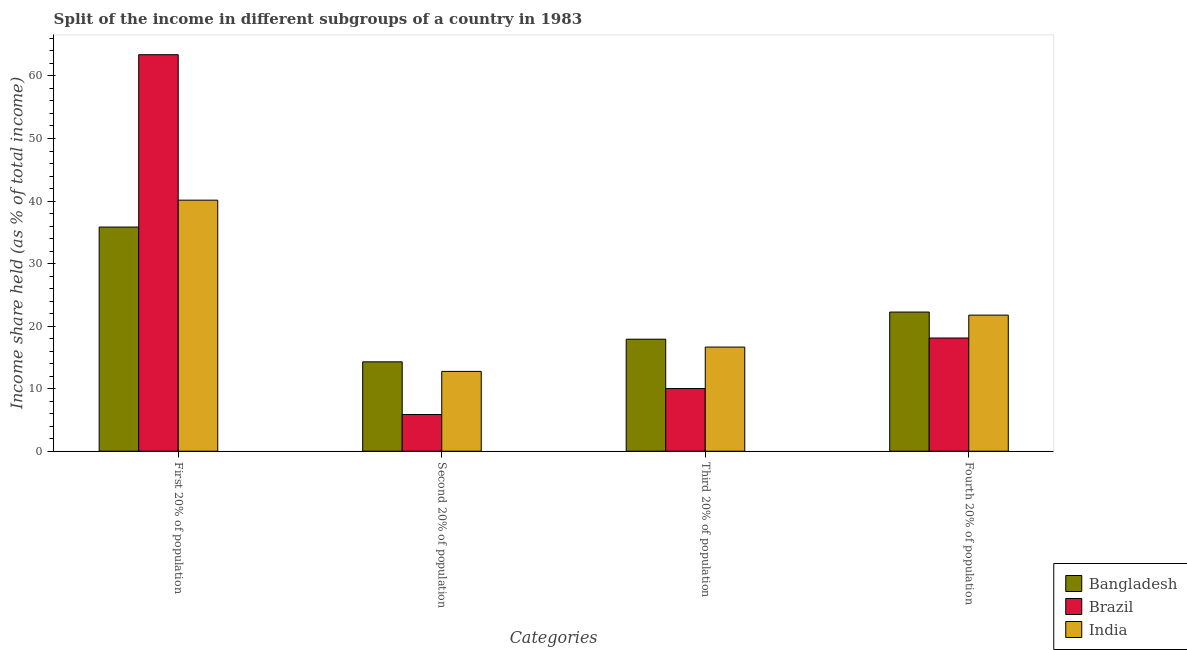How many different coloured bars are there?
Your answer should be compact. 3. How many groups of bars are there?
Your response must be concise. 4. Are the number of bars on each tick of the X-axis equal?
Your answer should be very brief. Yes. How many bars are there on the 1st tick from the left?
Your response must be concise. 3. What is the label of the 1st group of bars from the left?
Make the answer very short. First 20% of population. What is the share of the income held by second 20% of the population in Bangladesh?
Your response must be concise. 14.29. Across all countries, what is the maximum share of the income held by first 20% of the population?
Your answer should be compact. 63.4. In which country was the share of the income held by fourth 20% of the population maximum?
Provide a succinct answer. Bangladesh. What is the total share of the income held by third 20% of the population in the graph?
Your answer should be very brief. 44.58. What is the difference between the share of the income held by third 20% of the population in Bangladesh and that in India?
Offer a very short reply. 1.26. What is the difference between the share of the income held by third 20% of the population in Bangladesh and the share of the income held by second 20% of the population in India?
Your response must be concise. 5.15. What is the average share of the income held by third 20% of the population per country?
Offer a terse response. 14.86. What is the difference between the share of the income held by first 20% of the population and share of the income held by third 20% of the population in Brazil?
Offer a very short reply. 53.38. In how many countries, is the share of the income held by second 20% of the population greater than 56 %?
Your answer should be very brief. 0. What is the ratio of the share of the income held by second 20% of the population in Brazil to that in India?
Keep it short and to the point. 0.46. Is the share of the income held by first 20% of the population in Bangladesh less than that in Brazil?
Offer a very short reply. Yes. What is the difference between the highest and the second highest share of the income held by fourth 20% of the population?
Your response must be concise. 0.49. What is the difference between the highest and the lowest share of the income held by fourth 20% of the population?
Make the answer very short. 4.15. In how many countries, is the share of the income held by first 20% of the population greater than the average share of the income held by first 20% of the population taken over all countries?
Ensure brevity in your answer.  1. Is the sum of the share of the income held by first 20% of the population in India and Bangladesh greater than the maximum share of the income held by second 20% of the population across all countries?
Give a very brief answer. Yes. What does the 3rd bar from the left in Fourth 20% of population represents?
Offer a very short reply. India. Is it the case that in every country, the sum of the share of the income held by first 20% of the population and share of the income held by second 20% of the population is greater than the share of the income held by third 20% of the population?
Ensure brevity in your answer.  Yes. What is the difference between two consecutive major ticks on the Y-axis?
Your answer should be compact. 10. Does the graph contain any zero values?
Keep it short and to the point. No. Does the graph contain grids?
Offer a terse response. No. Where does the legend appear in the graph?
Your answer should be very brief. Bottom right. How are the legend labels stacked?
Provide a succinct answer. Vertical. What is the title of the graph?
Give a very brief answer. Split of the income in different subgroups of a country in 1983. Does "World" appear as one of the legend labels in the graph?
Ensure brevity in your answer.  No. What is the label or title of the X-axis?
Offer a very short reply. Categories. What is the label or title of the Y-axis?
Make the answer very short. Income share held (as % of total income). What is the Income share held (as % of total income) of Bangladesh in First 20% of population?
Provide a short and direct response. 35.84. What is the Income share held (as % of total income) of Brazil in First 20% of population?
Offer a very short reply. 63.4. What is the Income share held (as % of total income) of India in First 20% of population?
Ensure brevity in your answer.  40.14. What is the Income share held (as % of total income) in Bangladesh in Second 20% of population?
Your answer should be very brief. 14.29. What is the Income share held (as % of total income) of Brazil in Second 20% of population?
Your response must be concise. 5.87. What is the Income share held (as % of total income) of India in Second 20% of population?
Provide a short and direct response. 12.76. What is the Income share held (as % of total income) of Bangladesh in Third 20% of population?
Provide a succinct answer. 17.91. What is the Income share held (as % of total income) of Brazil in Third 20% of population?
Provide a succinct answer. 10.02. What is the Income share held (as % of total income) in India in Third 20% of population?
Offer a terse response. 16.65. What is the Income share held (as % of total income) in Bangladesh in Fourth 20% of population?
Offer a very short reply. 22.25. What is the Income share held (as % of total income) of India in Fourth 20% of population?
Keep it short and to the point. 21.76. Across all Categories, what is the maximum Income share held (as % of total income) of Bangladesh?
Keep it short and to the point. 35.84. Across all Categories, what is the maximum Income share held (as % of total income) in Brazil?
Your answer should be compact. 63.4. Across all Categories, what is the maximum Income share held (as % of total income) of India?
Provide a short and direct response. 40.14. Across all Categories, what is the minimum Income share held (as % of total income) in Bangladesh?
Offer a terse response. 14.29. Across all Categories, what is the minimum Income share held (as % of total income) of Brazil?
Your answer should be compact. 5.87. Across all Categories, what is the minimum Income share held (as % of total income) of India?
Give a very brief answer. 12.76. What is the total Income share held (as % of total income) in Bangladesh in the graph?
Give a very brief answer. 90.29. What is the total Income share held (as % of total income) of Brazil in the graph?
Provide a short and direct response. 97.39. What is the total Income share held (as % of total income) in India in the graph?
Offer a terse response. 91.31. What is the difference between the Income share held (as % of total income) of Bangladesh in First 20% of population and that in Second 20% of population?
Give a very brief answer. 21.55. What is the difference between the Income share held (as % of total income) of Brazil in First 20% of population and that in Second 20% of population?
Your answer should be compact. 57.53. What is the difference between the Income share held (as % of total income) in India in First 20% of population and that in Second 20% of population?
Make the answer very short. 27.38. What is the difference between the Income share held (as % of total income) of Bangladesh in First 20% of population and that in Third 20% of population?
Offer a very short reply. 17.93. What is the difference between the Income share held (as % of total income) of Brazil in First 20% of population and that in Third 20% of population?
Your answer should be compact. 53.38. What is the difference between the Income share held (as % of total income) in India in First 20% of population and that in Third 20% of population?
Provide a short and direct response. 23.49. What is the difference between the Income share held (as % of total income) of Bangladesh in First 20% of population and that in Fourth 20% of population?
Offer a very short reply. 13.59. What is the difference between the Income share held (as % of total income) of Brazil in First 20% of population and that in Fourth 20% of population?
Provide a short and direct response. 45.3. What is the difference between the Income share held (as % of total income) in India in First 20% of population and that in Fourth 20% of population?
Keep it short and to the point. 18.38. What is the difference between the Income share held (as % of total income) of Bangladesh in Second 20% of population and that in Third 20% of population?
Provide a short and direct response. -3.62. What is the difference between the Income share held (as % of total income) in Brazil in Second 20% of population and that in Third 20% of population?
Keep it short and to the point. -4.15. What is the difference between the Income share held (as % of total income) in India in Second 20% of population and that in Third 20% of population?
Your answer should be compact. -3.89. What is the difference between the Income share held (as % of total income) of Bangladesh in Second 20% of population and that in Fourth 20% of population?
Offer a very short reply. -7.96. What is the difference between the Income share held (as % of total income) of Brazil in Second 20% of population and that in Fourth 20% of population?
Offer a very short reply. -12.23. What is the difference between the Income share held (as % of total income) in India in Second 20% of population and that in Fourth 20% of population?
Provide a short and direct response. -9. What is the difference between the Income share held (as % of total income) of Bangladesh in Third 20% of population and that in Fourth 20% of population?
Ensure brevity in your answer.  -4.34. What is the difference between the Income share held (as % of total income) in Brazil in Third 20% of population and that in Fourth 20% of population?
Provide a short and direct response. -8.08. What is the difference between the Income share held (as % of total income) of India in Third 20% of population and that in Fourth 20% of population?
Make the answer very short. -5.11. What is the difference between the Income share held (as % of total income) of Bangladesh in First 20% of population and the Income share held (as % of total income) of Brazil in Second 20% of population?
Give a very brief answer. 29.97. What is the difference between the Income share held (as % of total income) of Bangladesh in First 20% of population and the Income share held (as % of total income) of India in Second 20% of population?
Your answer should be compact. 23.08. What is the difference between the Income share held (as % of total income) in Brazil in First 20% of population and the Income share held (as % of total income) in India in Second 20% of population?
Your answer should be very brief. 50.64. What is the difference between the Income share held (as % of total income) of Bangladesh in First 20% of population and the Income share held (as % of total income) of Brazil in Third 20% of population?
Your answer should be compact. 25.82. What is the difference between the Income share held (as % of total income) of Bangladesh in First 20% of population and the Income share held (as % of total income) of India in Third 20% of population?
Your response must be concise. 19.19. What is the difference between the Income share held (as % of total income) of Brazil in First 20% of population and the Income share held (as % of total income) of India in Third 20% of population?
Your answer should be compact. 46.75. What is the difference between the Income share held (as % of total income) of Bangladesh in First 20% of population and the Income share held (as % of total income) of Brazil in Fourth 20% of population?
Provide a short and direct response. 17.74. What is the difference between the Income share held (as % of total income) of Bangladesh in First 20% of population and the Income share held (as % of total income) of India in Fourth 20% of population?
Your answer should be very brief. 14.08. What is the difference between the Income share held (as % of total income) of Brazil in First 20% of population and the Income share held (as % of total income) of India in Fourth 20% of population?
Provide a short and direct response. 41.64. What is the difference between the Income share held (as % of total income) of Bangladesh in Second 20% of population and the Income share held (as % of total income) of Brazil in Third 20% of population?
Give a very brief answer. 4.27. What is the difference between the Income share held (as % of total income) in Bangladesh in Second 20% of population and the Income share held (as % of total income) in India in Third 20% of population?
Provide a succinct answer. -2.36. What is the difference between the Income share held (as % of total income) of Brazil in Second 20% of population and the Income share held (as % of total income) of India in Third 20% of population?
Your answer should be compact. -10.78. What is the difference between the Income share held (as % of total income) of Bangladesh in Second 20% of population and the Income share held (as % of total income) of Brazil in Fourth 20% of population?
Your answer should be very brief. -3.81. What is the difference between the Income share held (as % of total income) of Bangladesh in Second 20% of population and the Income share held (as % of total income) of India in Fourth 20% of population?
Provide a short and direct response. -7.47. What is the difference between the Income share held (as % of total income) in Brazil in Second 20% of population and the Income share held (as % of total income) in India in Fourth 20% of population?
Provide a short and direct response. -15.89. What is the difference between the Income share held (as % of total income) in Bangladesh in Third 20% of population and the Income share held (as % of total income) in Brazil in Fourth 20% of population?
Offer a very short reply. -0.19. What is the difference between the Income share held (as % of total income) in Bangladesh in Third 20% of population and the Income share held (as % of total income) in India in Fourth 20% of population?
Provide a succinct answer. -3.85. What is the difference between the Income share held (as % of total income) of Brazil in Third 20% of population and the Income share held (as % of total income) of India in Fourth 20% of population?
Your answer should be compact. -11.74. What is the average Income share held (as % of total income) of Bangladesh per Categories?
Provide a succinct answer. 22.57. What is the average Income share held (as % of total income) of Brazil per Categories?
Provide a succinct answer. 24.35. What is the average Income share held (as % of total income) in India per Categories?
Your answer should be very brief. 22.83. What is the difference between the Income share held (as % of total income) in Bangladesh and Income share held (as % of total income) in Brazil in First 20% of population?
Provide a succinct answer. -27.56. What is the difference between the Income share held (as % of total income) in Bangladesh and Income share held (as % of total income) in India in First 20% of population?
Offer a terse response. -4.3. What is the difference between the Income share held (as % of total income) of Brazil and Income share held (as % of total income) of India in First 20% of population?
Your answer should be very brief. 23.26. What is the difference between the Income share held (as % of total income) of Bangladesh and Income share held (as % of total income) of Brazil in Second 20% of population?
Ensure brevity in your answer.  8.42. What is the difference between the Income share held (as % of total income) of Bangladesh and Income share held (as % of total income) of India in Second 20% of population?
Give a very brief answer. 1.53. What is the difference between the Income share held (as % of total income) in Brazil and Income share held (as % of total income) in India in Second 20% of population?
Offer a terse response. -6.89. What is the difference between the Income share held (as % of total income) in Bangladesh and Income share held (as % of total income) in Brazil in Third 20% of population?
Your answer should be compact. 7.89. What is the difference between the Income share held (as % of total income) of Bangladesh and Income share held (as % of total income) of India in Third 20% of population?
Provide a short and direct response. 1.26. What is the difference between the Income share held (as % of total income) of Brazil and Income share held (as % of total income) of India in Third 20% of population?
Your answer should be compact. -6.63. What is the difference between the Income share held (as % of total income) in Bangladesh and Income share held (as % of total income) in Brazil in Fourth 20% of population?
Provide a succinct answer. 4.15. What is the difference between the Income share held (as % of total income) of Bangladesh and Income share held (as % of total income) of India in Fourth 20% of population?
Your answer should be compact. 0.49. What is the difference between the Income share held (as % of total income) of Brazil and Income share held (as % of total income) of India in Fourth 20% of population?
Offer a terse response. -3.66. What is the ratio of the Income share held (as % of total income) of Bangladesh in First 20% of population to that in Second 20% of population?
Make the answer very short. 2.51. What is the ratio of the Income share held (as % of total income) in Brazil in First 20% of population to that in Second 20% of population?
Give a very brief answer. 10.8. What is the ratio of the Income share held (as % of total income) in India in First 20% of population to that in Second 20% of population?
Your response must be concise. 3.15. What is the ratio of the Income share held (as % of total income) of Bangladesh in First 20% of population to that in Third 20% of population?
Your answer should be very brief. 2. What is the ratio of the Income share held (as % of total income) of Brazil in First 20% of population to that in Third 20% of population?
Your response must be concise. 6.33. What is the ratio of the Income share held (as % of total income) of India in First 20% of population to that in Third 20% of population?
Offer a very short reply. 2.41. What is the ratio of the Income share held (as % of total income) of Bangladesh in First 20% of population to that in Fourth 20% of population?
Your response must be concise. 1.61. What is the ratio of the Income share held (as % of total income) of Brazil in First 20% of population to that in Fourth 20% of population?
Offer a very short reply. 3.5. What is the ratio of the Income share held (as % of total income) in India in First 20% of population to that in Fourth 20% of population?
Offer a very short reply. 1.84. What is the ratio of the Income share held (as % of total income) in Bangladesh in Second 20% of population to that in Third 20% of population?
Give a very brief answer. 0.8. What is the ratio of the Income share held (as % of total income) of Brazil in Second 20% of population to that in Third 20% of population?
Your answer should be very brief. 0.59. What is the ratio of the Income share held (as % of total income) in India in Second 20% of population to that in Third 20% of population?
Your answer should be very brief. 0.77. What is the ratio of the Income share held (as % of total income) of Bangladesh in Second 20% of population to that in Fourth 20% of population?
Your answer should be very brief. 0.64. What is the ratio of the Income share held (as % of total income) in Brazil in Second 20% of population to that in Fourth 20% of population?
Ensure brevity in your answer.  0.32. What is the ratio of the Income share held (as % of total income) in India in Second 20% of population to that in Fourth 20% of population?
Keep it short and to the point. 0.59. What is the ratio of the Income share held (as % of total income) in Bangladesh in Third 20% of population to that in Fourth 20% of population?
Provide a succinct answer. 0.8. What is the ratio of the Income share held (as % of total income) in Brazil in Third 20% of population to that in Fourth 20% of population?
Offer a very short reply. 0.55. What is the ratio of the Income share held (as % of total income) in India in Third 20% of population to that in Fourth 20% of population?
Provide a short and direct response. 0.77. What is the difference between the highest and the second highest Income share held (as % of total income) in Bangladesh?
Provide a short and direct response. 13.59. What is the difference between the highest and the second highest Income share held (as % of total income) of Brazil?
Make the answer very short. 45.3. What is the difference between the highest and the second highest Income share held (as % of total income) of India?
Your response must be concise. 18.38. What is the difference between the highest and the lowest Income share held (as % of total income) in Bangladesh?
Your answer should be very brief. 21.55. What is the difference between the highest and the lowest Income share held (as % of total income) of Brazil?
Provide a short and direct response. 57.53. What is the difference between the highest and the lowest Income share held (as % of total income) in India?
Your answer should be very brief. 27.38. 